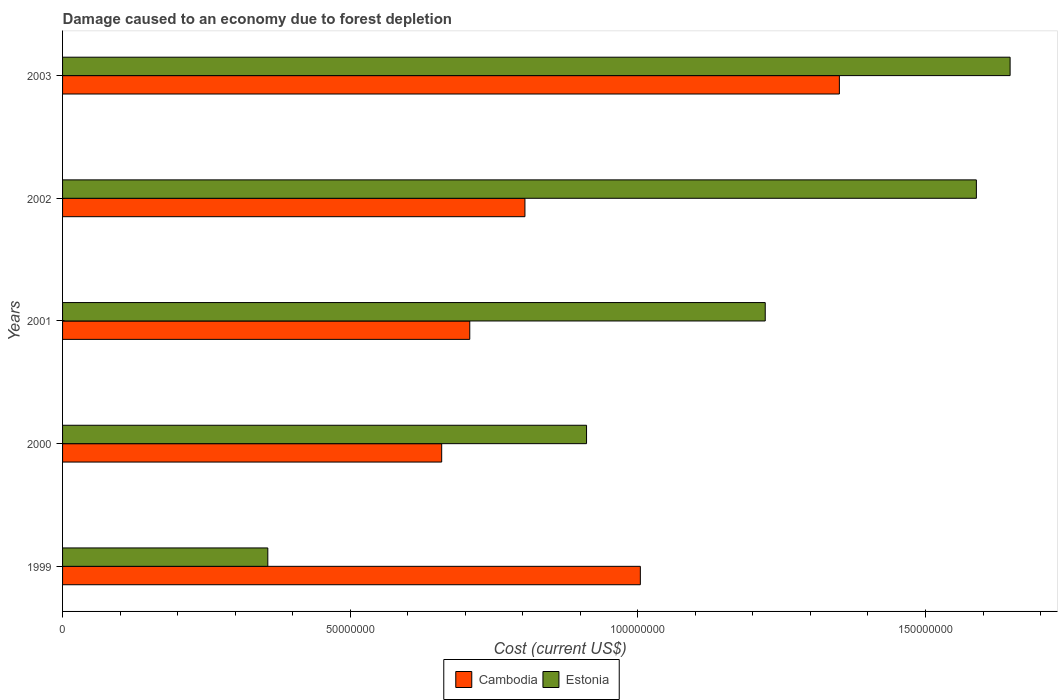How many different coloured bars are there?
Offer a terse response. 2. Are the number of bars on each tick of the Y-axis equal?
Your answer should be very brief. Yes. What is the cost of damage caused due to forest depletion in Estonia in 2001?
Offer a terse response. 1.22e+08. Across all years, what is the maximum cost of damage caused due to forest depletion in Estonia?
Keep it short and to the point. 1.65e+08. Across all years, what is the minimum cost of damage caused due to forest depletion in Cambodia?
Give a very brief answer. 6.59e+07. In which year was the cost of damage caused due to forest depletion in Cambodia maximum?
Provide a succinct answer. 2003. What is the total cost of damage caused due to forest depletion in Estonia in the graph?
Keep it short and to the point. 5.72e+08. What is the difference between the cost of damage caused due to forest depletion in Estonia in 1999 and that in 2003?
Make the answer very short. -1.29e+08. What is the difference between the cost of damage caused due to forest depletion in Cambodia in 2001 and the cost of damage caused due to forest depletion in Estonia in 2003?
Offer a very short reply. -9.39e+07. What is the average cost of damage caused due to forest depletion in Cambodia per year?
Give a very brief answer. 9.05e+07. In the year 1999, what is the difference between the cost of damage caused due to forest depletion in Estonia and cost of damage caused due to forest depletion in Cambodia?
Your answer should be compact. -6.48e+07. What is the ratio of the cost of damage caused due to forest depletion in Cambodia in 1999 to that in 2002?
Ensure brevity in your answer.  1.25. What is the difference between the highest and the second highest cost of damage caused due to forest depletion in Cambodia?
Give a very brief answer. 3.46e+07. What is the difference between the highest and the lowest cost of damage caused due to forest depletion in Estonia?
Ensure brevity in your answer.  1.29e+08. What does the 1st bar from the top in 2000 represents?
Your answer should be very brief. Estonia. What does the 2nd bar from the bottom in 2001 represents?
Keep it short and to the point. Estonia. How many years are there in the graph?
Make the answer very short. 5. What is the difference between two consecutive major ticks on the X-axis?
Offer a very short reply. 5.00e+07. Are the values on the major ticks of X-axis written in scientific E-notation?
Keep it short and to the point. No. Where does the legend appear in the graph?
Ensure brevity in your answer.  Bottom center. How many legend labels are there?
Provide a short and direct response. 2. How are the legend labels stacked?
Offer a terse response. Horizontal. What is the title of the graph?
Offer a terse response. Damage caused to an economy due to forest depletion. What is the label or title of the X-axis?
Give a very brief answer. Cost (current US$). What is the Cost (current US$) of Cambodia in 1999?
Keep it short and to the point. 1.00e+08. What is the Cost (current US$) of Estonia in 1999?
Offer a terse response. 3.57e+07. What is the Cost (current US$) of Cambodia in 2000?
Make the answer very short. 6.59e+07. What is the Cost (current US$) in Estonia in 2000?
Provide a short and direct response. 9.11e+07. What is the Cost (current US$) in Cambodia in 2001?
Your response must be concise. 7.08e+07. What is the Cost (current US$) in Estonia in 2001?
Your answer should be compact. 1.22e+08. What is the Cost (current US$) in Cambodia in 2002?
Provide a short and direct response. 8.04e+07. What is the Cost (current US$) of Estonia in 2002?
Your answer should be compact. 1.59e+08. What is the Cost (current US$) of Cambodia in 2003?
Offer a very short reply. 1.35e+08. What is the Cost (current US$) in Estonia in 2003?
Your answer should be very brief. 1.65e+08. Across all years, what is the maximum Cost (current US$) of Cambodia?
Your answer should be very brief. 1.35e+08. Across all years, what is the maximum Cost (current US$) of Estonia?
Provide a succinct answer. 1.65e+08. Across all years, what is the minimum Cost (current US$) of Cambodia?
Make the answer very short. 6.59e+07. Across all years, what is the minimum Cost (current US$) of Estonia?
Give a very brief answer. 3.57e+07. What is the total Cost (current US$) in Cambodia in the graph?
Keep it short and to the point. 4.53e+08. What is the total Cost (current US$) of Estonia in the graph?
Make the answer very short. 5.72e+08. What is the difference between the Cost (current US$) of Cambodia in 1999 and that in 2000?
Provide a short and direct response. 3.45e+07. What is the difference between the Cost (current US$) of Estonia in 1999 and that in 2000?
Make the answer very short. -5.54e+07. What is the difference between the Cost (current US$) of Cambodia in 1999 and that in 2001?
Ensure brevity in your answer.  2.97e+07. What is the difference between the Cost (current US$) in Estonia in 1999 and that in 2001?
Your response must be concise. -8.65e+07. What is the difference between the Cost (current US$) in Cambodia in 1999 and that in 2002?
Your answer should be compact. 2.01e+07. What is the difference between the Cost (current US$) of Estonia in 1999 and that in 2002?
Give a very brief answer. -1.23e+08. What is the difference between the Cost (current US$) in Cambodia in 1999 and that in 2003?
Ensure brevity in your answer.  -3.46e+07. What is the difference between the Cost (current US$) in Estonia in 1999 and that in 2003?
Give a very brief answer. -1.29e+08. What is the difference between the Cost (current US$) of Cambodia in 2000 and that in 2001?
Give a very brief answer. -4.88e+06. What is the difference between the Cost (current US$) of Estonia in 2000 and that in 2001?
Offer a very short reply. -3.11e+07. What is the difference between the Cost (current US$) of Cambodia in 2000 and that in 2002?
Make the answer very short. -1.45e+07. What is the difference between the Cost (current US$) of Estonia in 2000 and that in 2002?
Your response must be concise. -6.78e+07. What is the difference between the Cost (current US$) in Cambodia in 2000 and that in 2003?
Make the answer very short. -6.91e+07. What is the difference between the Cost (current US$) in Estonia in 2000 and that in 2003?
Give a very brief answer. -7.36e+07. What is the difference between the Cost (current US$) in Cambodia in 2001 and that in 2002?
Your answer should be very brief. -9.59e+06. What is the difference between the Cost (current US$) in Estonia in 2001 and that in 2002?
Offer a terse response. -3.67e+07. What is the difference between the Cost (current US$) in Cambodia in 2001 and that in 2003?
Your response must be concise. -6.42e+07. What is the difference between the Cost (current US$) in Estonia in 2001 and that in 2003?
Your answer should be very brief. -4.26e+07. What is the difference between the Cost (current US$) in Cambodia in 2002 and that in 2003?
Give a very brief answer. -5.47e+07. What is the difference between the Cost (current US$) of Estonia in 2002 and that in 2003?
Provide a succinct answer. -5.87e+06. What is the difference between the Cost (current US$) of Cambodia in 1999 and the Cost (current US$) of Estonia in 2000?
Provide a short and direct response. 9.35e+06. What is the difference between the Cost (current US$) in Cambodia in 1999 and the Cost (current US$) in Estonia in 2001?
Provide a short and direct response. -2.17e+07. What is the difference between the Cost (current US$) in Cambodia in 1999 and the Cost (current US$) in Estonia in 2002?
Your response must be concise. -5.84e+07. What is the difference between the Cost (current US$) of Cambodia in 1999 and the Cost (current US$) of Estonia in 2003?
Offer a terse response. -6.43e+07. What is the difference between the Cost (current US$) of Cambodia in 2000 and the Cost (current US$) of Estonia in 2001?
Offer a terse response. -5.62e+07. What is the difference between the Cost (current US$) in Cambodia in 2000 and the Cost (current US$) in Estonia in 2002?
Your answer should be compact. -9.29e+07. What is the difference between the Cost (current US$) of Cambodia in 2000 and the Cost (current US$) of Estonia in 2003?
Your response must be concise. -9.88e+07. What is the difference between the Cost (current US$) in Cambodia in 2001 and the Cost (current US$) in Estonia in 2002?
Offer a very short reply. -8.81e+07. What is the difference between the Cost (current US$) of Cambodia in 2001 and the Cost (current US$) of Estonia in 2003?
Keep it short and to the point. -9.39e+07. What is the difference between the Cost (current US$) of Cambodia in 2002 and the Cost (current US$) of Estonia in 2003?
Give a very brief answer. -8.43e+07. What is the average Cost (current US$) in Cambodia per year?
Offer a very short reply. 9.05e+07. What is the average Cost (current US$) in Estonia per year?
Offer a terse response. 1.14e+08. In the year 1999, what is the difference between the Cost (current US$) in Cambodia and Cost (current US$) in Estonia?
Give a very brief answer. 6.48e+07. In the year 2000, what is the difference between the Cost (current US$) of Cambodia and Cost (current US$) of Estonia?
Offer a very short reply. -2.52e+07. In the year 2001, what is the difference between the Cost (current US$) in Cambodia and Cost (current US$) in Estonia?
Ensure brevity in your answer.  -5.14e+07. In the year 2002, what is the difference between the Cost (current US$) of Cambodia and Cost (current US$) of Estonia?
Provide a succinct answer. -7.85e+07. In the year 2003, what is the difference between the Cost (current US$) in Cambodia and Cost (current US$) in Estonia?
Your response must be concise. -2.97e+07. What is the ratio of the Cost (current US$) in Cambodia in 1999 to that in 2000?
Make the answer very short. 1.52. What is the ratio of the Cost (current US$) in Estonia in 1999 to that in 2000?
Your answer should be very brief. 0.39. What is the ratio of the Cost (current US$) in Cambodia in 1999 to that in 2001?
Give a very brief answer. 1.42. What is the ratio of the Cost (current US$) of Estonia in 1999 to that in 2001?
Ensure brevity in your answer.  0.29. What is the ratio of the Cost (current US$) in Cambodia in 1999 to that in 2002?
Provide a succinct answer. 1.25. What is the ratio of the Cost (current US$) in Estonia in 1999 to that in 2002?
Give a very brief answer. 0.22. What is the ratio of the Cost (current US$) of Cambodia in 1999 to that in 2003?
Give a very brief answer. 0.74. What is the ratio of the Cost (current US$) in Estonia in 1999 to that in 2003?
Your answer should be very brief. 0.22. What is the ratio of the Cost (current US$) in Estonia in 2000 to that in 2001?
Give a very brief answer. 0.75. What is the ratio of the Cost (current US$) in Cambodia in 2000 to that in 2002?
Offer a very short reply. 0.82. What is the ratio of the Cost (current US$) in Estonia in 2000 to that in 2002?
Your answer should be compact. 0.57. What is the ratio of the Cost (current US$) in Cambodia in 2000 to that in 2003?
Keep it short and to the point. 0.49. What is the ratio of the Cost (current US$) of Estonia in 2000 to that in 2003?
Your answer should be very brief. 0.55. What is the ratio of the Cost (current US$) of Cambodia in 2001 to that in 2002?
Ensure brevity in your answer.  0.88. What is the ratio of the Cost (current US$) in Estonia in 2001 to that in 2002?
Offer a terse response. 0.77. What is the ratio of the Cost (current US$) in Cambodia in 2001 to that in 2003?
Your answer should be compact. 0.52. What is the ratio of the Cost (current US$) of Estonia in 2001 to that in 2003?
Provide a succinct answer. 0.74. What is the ratio of the Cost (current US$) in Cambodia in 2002 to that in 2003?
Provide a short and direct response. 0.6. What is the ratio of the Cost (current US$) of Estonia in 2002 to that in 2003?
Ensure brevity in your answer.  0.96. What is the difference between the highest and the second highest Cost (current US$) of Cambodia?
Offer a very short reply. 3.46e+07. What is the difference between the highest and the second highest Cost (current US$) in Estonia?
Keep it short and to the point. 5.87e+06. What is the difference between the highest and the lowest Cost (current US$) of Cambodia?
Provide a succinct answer. 6.91e+07. What is the difference between the highest and the lowest Cost (current US$) in Estonia?
Offer a terse response. 1.29e+08. 